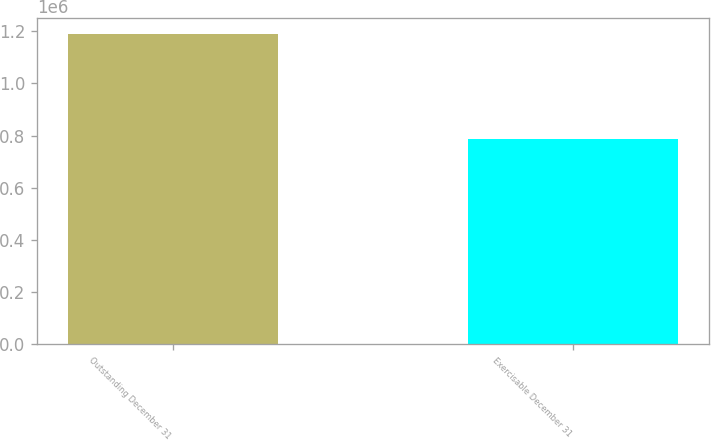<chart> <loc_0><loc_0><loc_500><loc_500><bar_chart><fcel>Outstanding December 31<fcel>Exercisable December 31<nl><fcel>1.19115e+06<fcel>788217<nl></chart> 